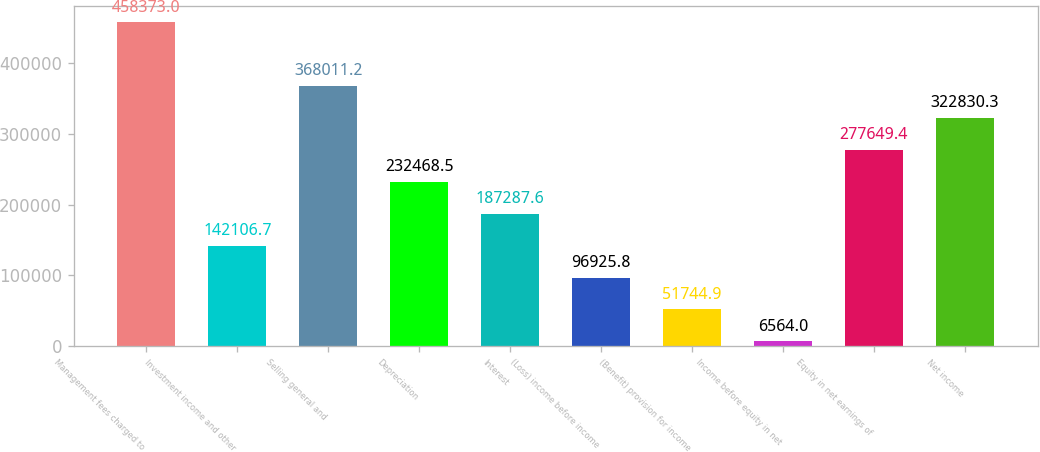Convert chart. <chart><loc_0><loc_0><loc_500><loc_500><bar_chart><fcel>Management fees charged to<fcel>Investment income and other<fcel>Selling general and<fcel>Depreciation<fcel>Interest<fcel>(Loss) income before income<fcel>(Benefit) provision for income<fcel>Income before equity in net<fcel>Equity in net earnings of<fcel>Net income<nl><fcel>458373<fcel>142107<fcel>368011<fcel>232468<fcel>187288<fcel>96925.8<fcel>51744.9<fcel>6564<fcel>277649<fcel>322830<nl></chart> 